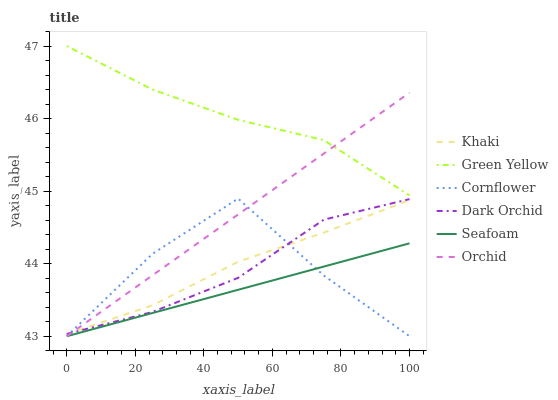Does Seafoam have the minimum area under the curve?
Answer yes or no. Yes. Does Green Yellow have the maximum area under the curve?
Answer yes or no. Yes. Does Khaki have the minimum area under the curve?
Answer yes or no. No. Does Khaki have the maximum area under the curve?
Answer yes or no. No. Is Seafoam the smoothest?
Answer yes or no. Yes. Is Cornflower the roughest?
Answer yes or no. Yes. Is Khaki the smoothest?
Answer yes or no. No. Is Khaki the roughest?
Answer yes or no. No. Does Cornflower have the lowest value?
Answer yes or no. Yes. Does Khaki have the lowest value?
Answer yes or no. No. Does Green Yellow have the highest value?
Answer yes or no. Yes. Does Khaki have the highest value?
Answer yes or no. No. Is Seafoam less than Khaki?
Answer yes or no. Yes. Is Green Yellow greater than Cornflower?
Answer yes or no. Yes. Does Dark Orchid intersect Cornflower?
Answer yes or no. Yes. Is Dark Orchid less than Cornflower?
Answer yes or no. No. Is Dark Orchid greater than Cornflower?
Answer yes or no. No. Does Seafoam intersect Khaki?
Answer yes or no. No. 